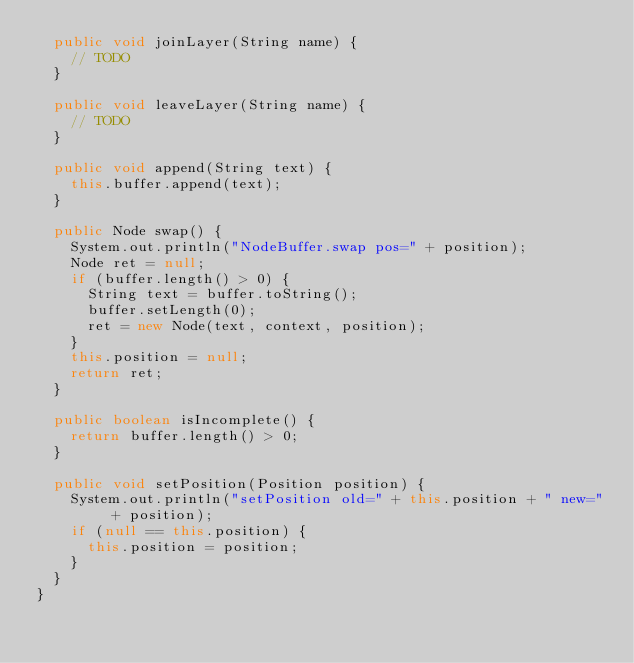<code> <loc_0><loc_0><loc_500><loc_500><_Java_>	public void joinLayer(String name) {
		// TODO
	}

	public void leaveLayer(String name) {
		// TODO
	}

	public void append(String text) {
		this.buffer.append(text);
	}

	public Node swap() {
		System.out.println("NodeBuffer.swap pos=" + position);
		Node ret = null;
		if (buffer.length() > 0) {
			String text = buffer.toString();
			buffer.setLength(0);
			ret = new Node(text, context, position);
		}
		this.position = null;
		return ret;
	}

	public boolean isIncomplete() {
		return buffer.length() > 0;
	}

	public void setPosition(Position position) {
		System.out.println("setPosition old=" + this.position + " new=" + position);
		if (null == this.position) {
			this.position = position;
		}
	}
}
</code> 